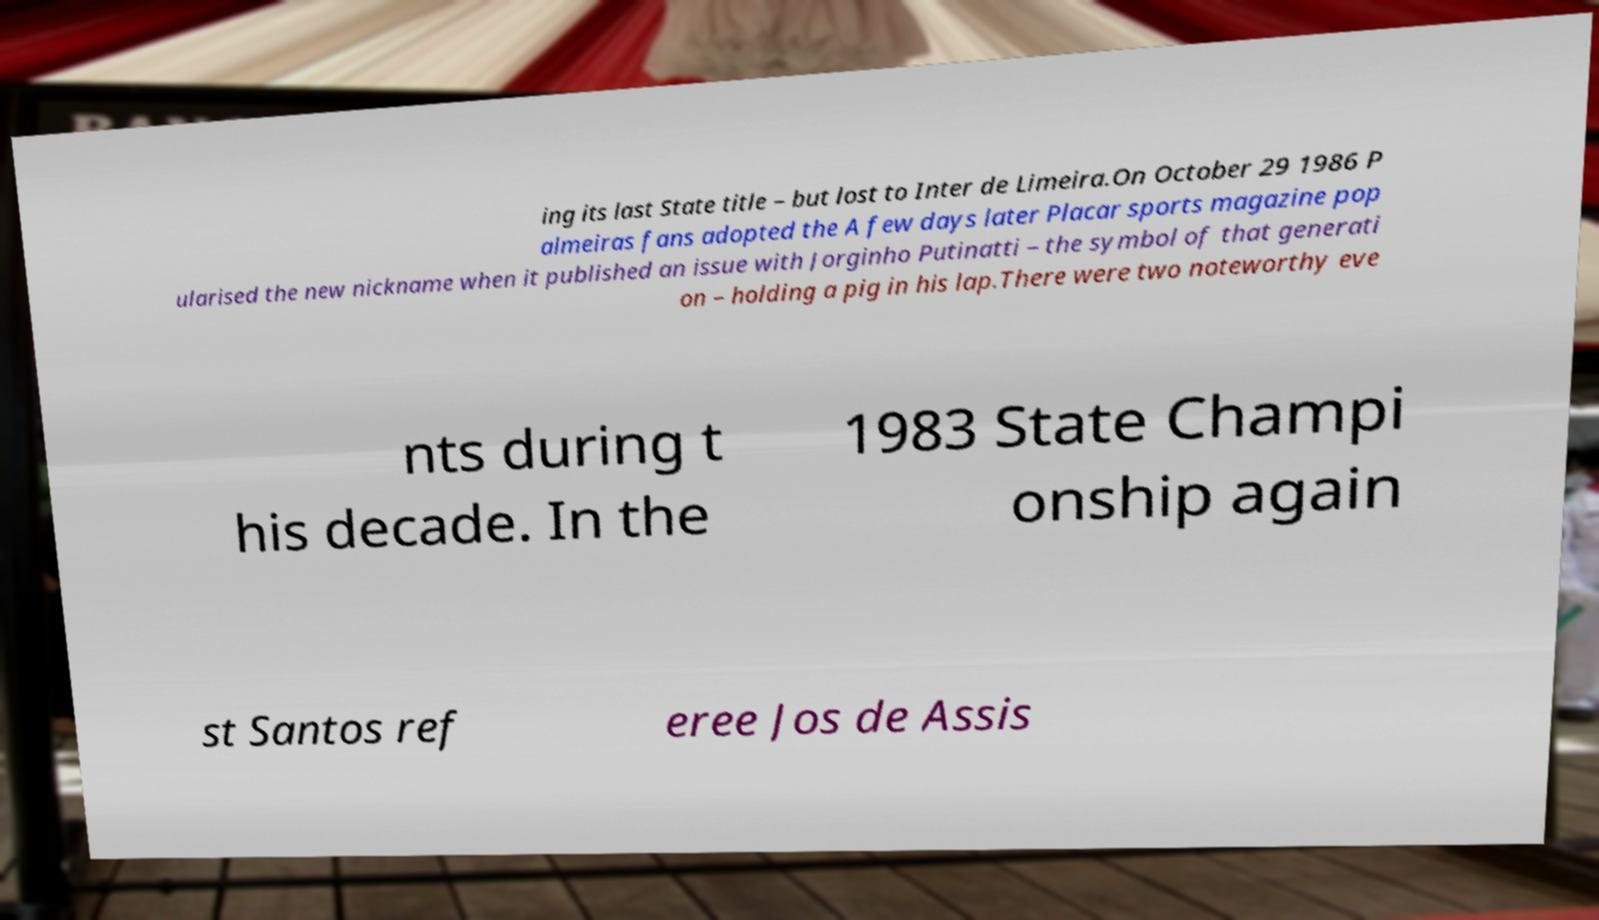What messages or text are displayed in this image? I need them in a readable, typed format. ing its last State title – but lost to Inter de Limeira.On October 29 1986 P almeiras fans adopted the A few days later Placar sports magazine pop ularised the new nickname when it published an issue with Jorginho Putinatti – the symbol of that generati on – holding a pig in his lap.There were two noteworthy eve nts during t his decade. In the 1983 State Champi onship again st Santos ref eree Jos de Assis 